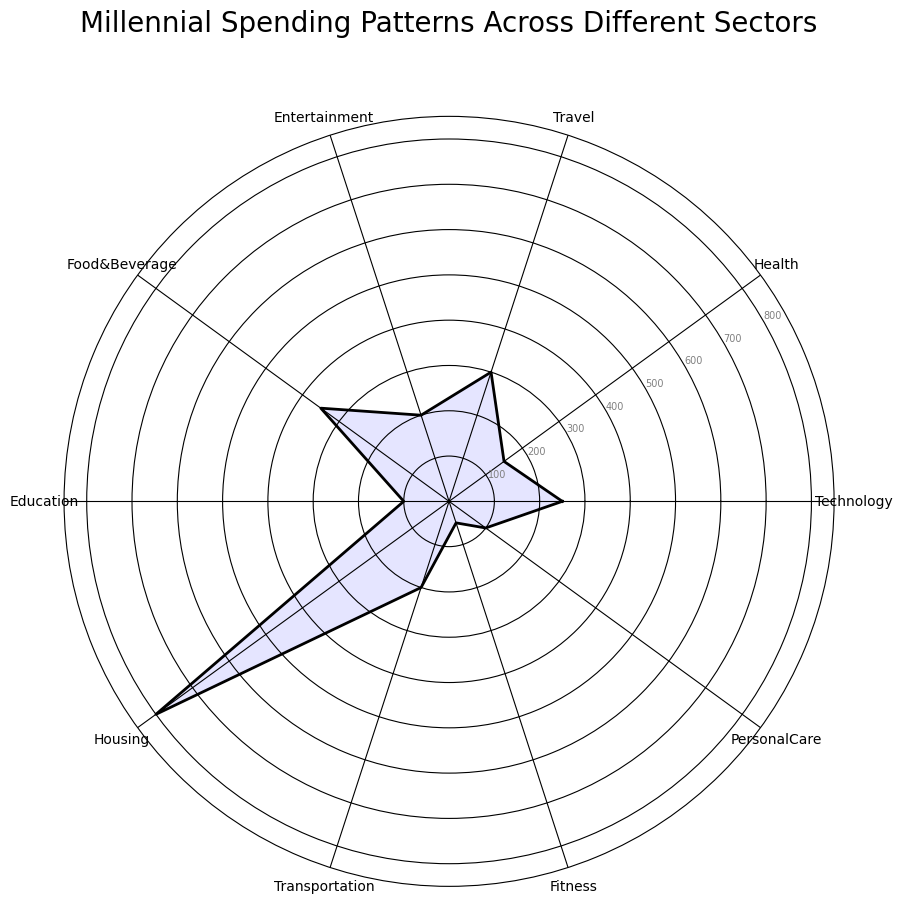What category has the highest average monthly spending? By observing the radar chart, we find that the category with the longest extension towards the edge, indicating the highest value, is Housing.
Answer: Housing What is the total average monthly spending for Health, Personal Care, and Fitness combined? From the radar chart, identify the values for Health (150), Personal Care (100), and Fitness (50). Add these together: 150 + 100 + 50 = 300.
Answer: 300 Which two sectors have the same average monthly spending? By examining the lengths of the chart extensions, it appears that both Transportation and Entertainment have the same value of 200.
Answer: Transportation and Entertainment How much more do millennials spend on Food & Beverage compared to Education? Identify the values for Food & Beverage (350) and Education (100). Calculate the difference: 350 - 100 = 250.
Answer: 250 What is the difference in spending between the highest and lowest spending categories? The highest category is Housing (800) and the lowest is Fitness (50). Calculate the difference: 800 - 50 = 750.
Answer: 750 Which categories have an average monthly spending of 200? Observing the radar chart, both Entertainment and Transportation have values marked at 200.
Answer: Entertainment and Transportation If you sum the spending for Technology, Travel, and Fitness, what is the result? Find the values for Technology (250), Travel (300), and Fitness (50). Add these together: 250 + 300 + 50 = 600.
Answer: 600 What is the median value of the spending categories? Arrange the values in ascending order: 50, 100, 100, 150, 200, 200, 250, 300, 350, 800. The median value is the average of the 5th and 6th values: (200 + 200) / 2 = 200.
Answer: 200 